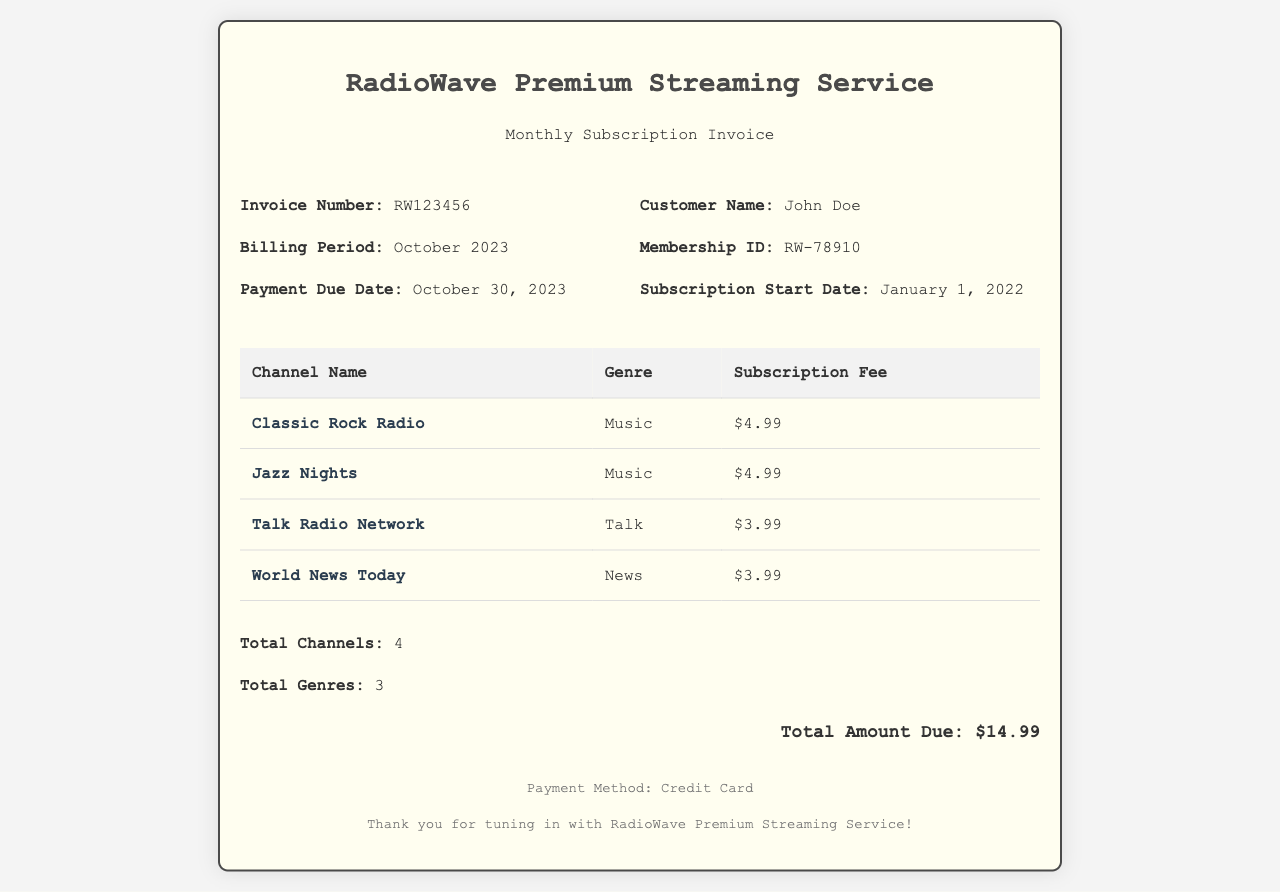What is the invoice number? The invoice number is listed under the invoice details section in the document.
Answer: RW123456 What is the billing period? The billing period is specified alongside the invoice number and customer details.
Answer: October 2023 How many total channels are included? The total number of channels is stated in a summary section towards the end of the invoice.
Answer: 4 What is the subscription fee for Jazz Nights? The subscription fee for each channel is found in the table that lists channel names and fees.
Answer: $4.99 What genre does the Talk Radio Network belong to? The genre for each channel can be found in the same table that includes their names.
Answer: Talk What is the total amount due? The total amount due is prominently displayed at the bottom of the invoice.
Answer: $14.99 When is the payment due date? The payment due date is detailed in the invoice information section.
Answer: October 30, 2023 Who is the customer? Customer information is provided in the invoice details section.
Answer: John Doe How many total genres are listed? The total genres are summarized at the end of the invoice after the channel breakdown.
Answer: 3 